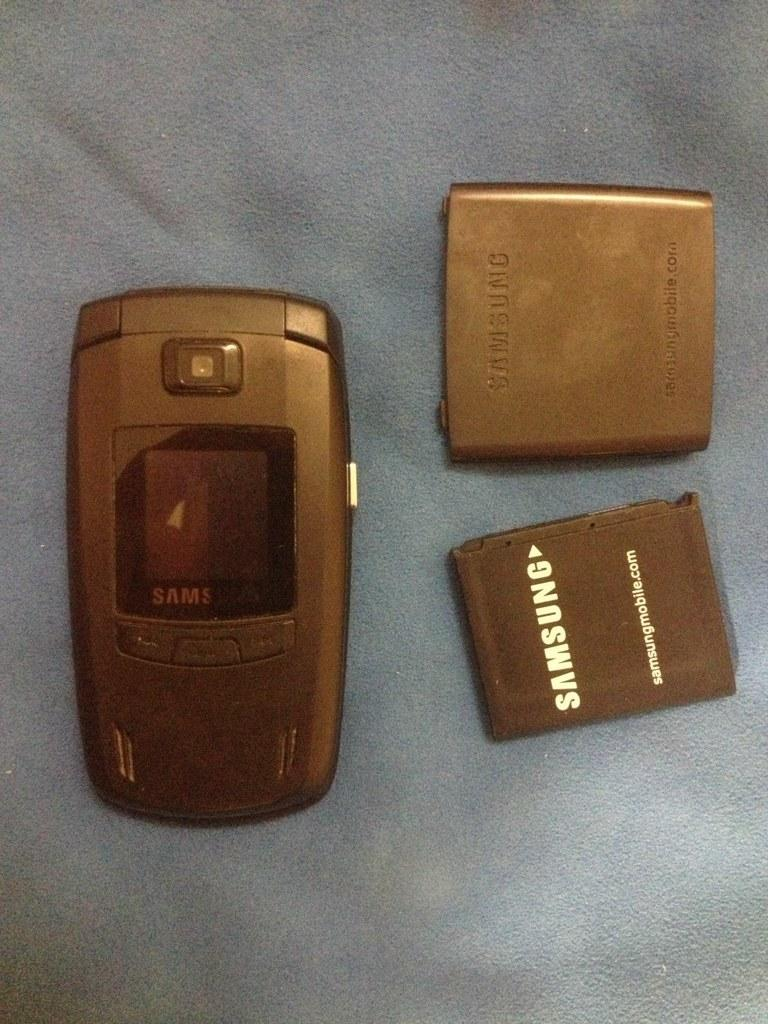<image>
Render a clear and concise summary of the photo. Three parts of a Samsung electronic device are laid out on a piece of gray cloth. 